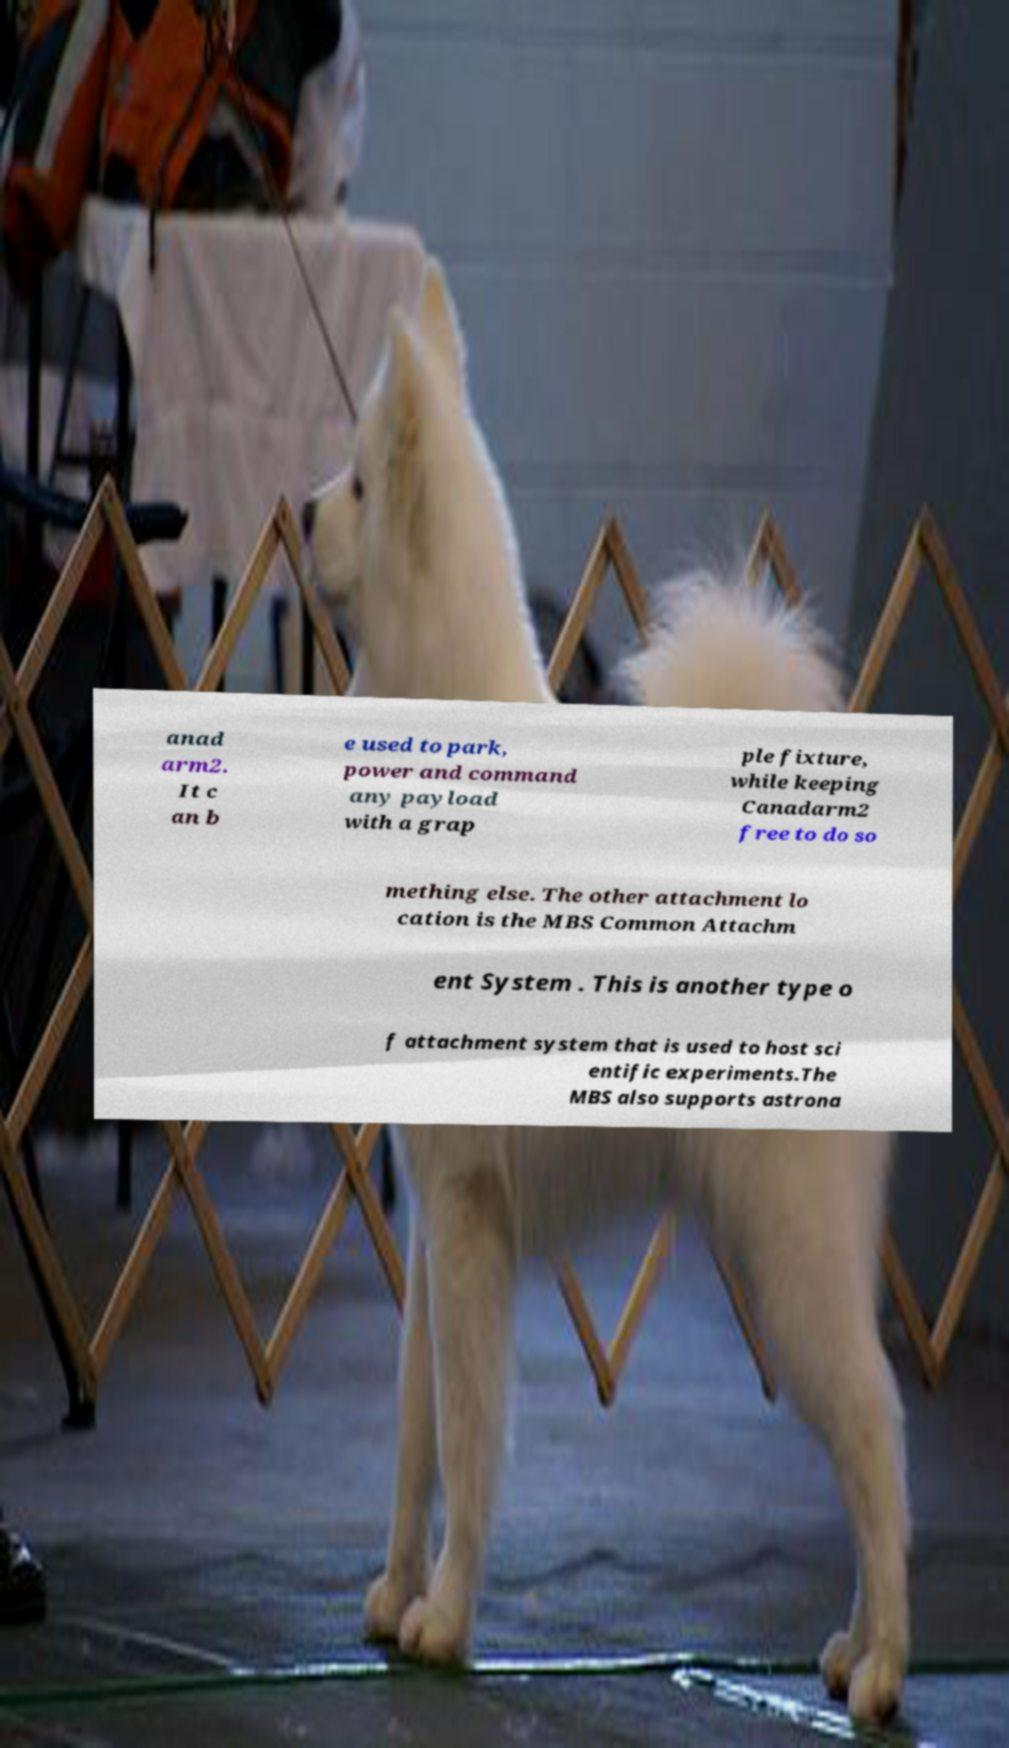Could you assist in decoding the text presented in this image and type it out clearly? anad arm2. It c an b e used to park, power and command any payload with a grap ple fixture, while keeping Canadarm2 free to do so mething else. The other attachment lo cation is the MBS Common Attachm ent System . This is another type o f attachment system that is used to host sci entific experiments.The MBS also supports astrona 